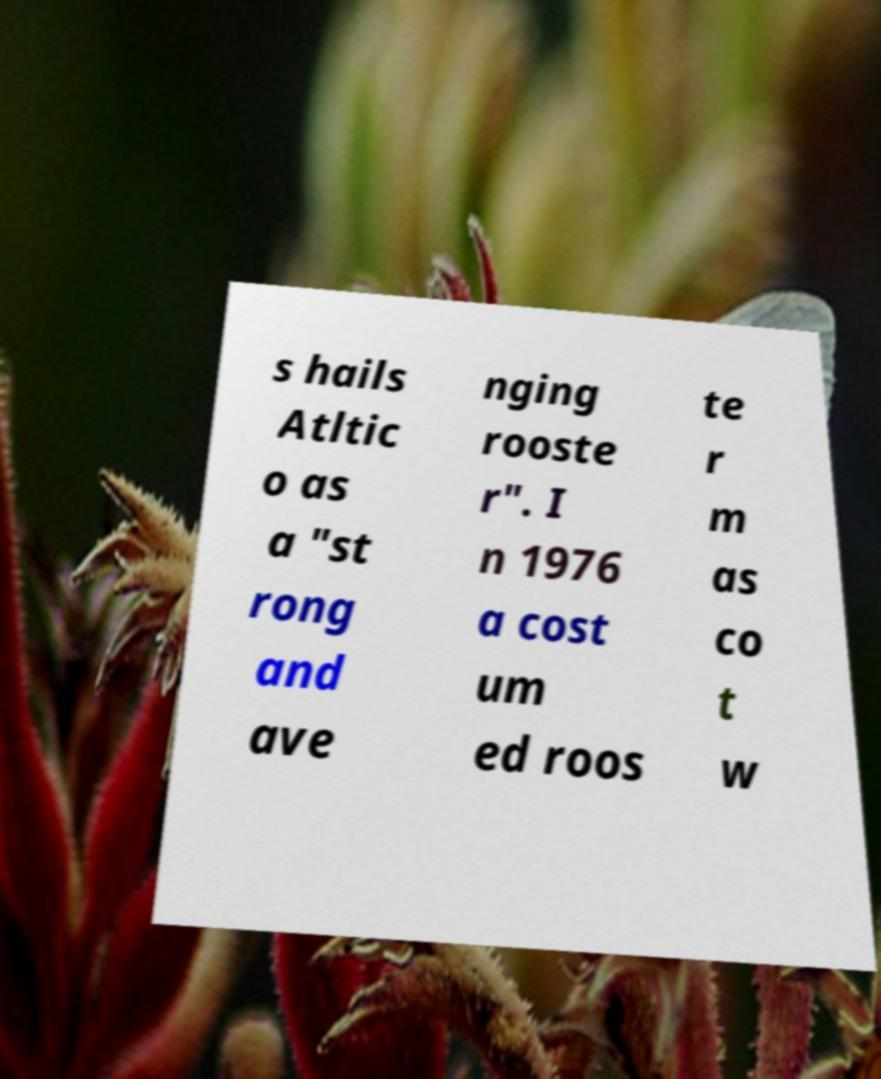For documentation purposes, I need the text within this image transcribed. Could you provide that? s hails Atltic o as a "st rong and ave nging rooste r". I n 1976 a cost um ed roos te r m as co t w 